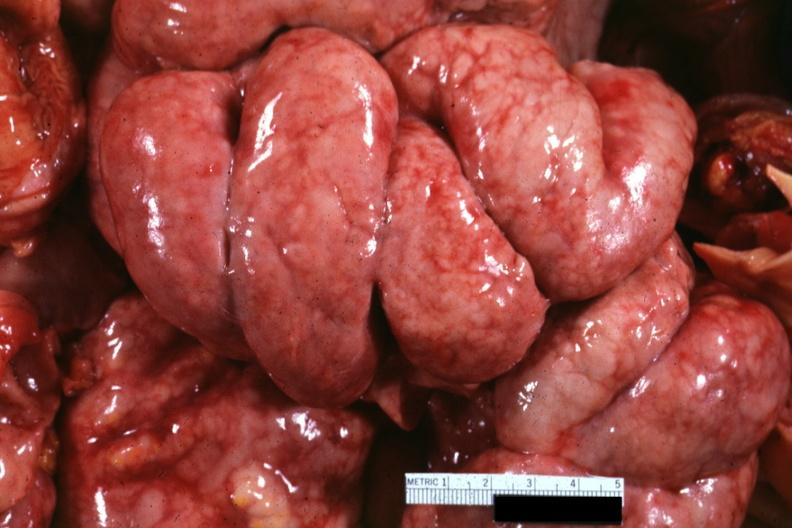what is present?
Answer the question using a single word or phrase. Abdomen 